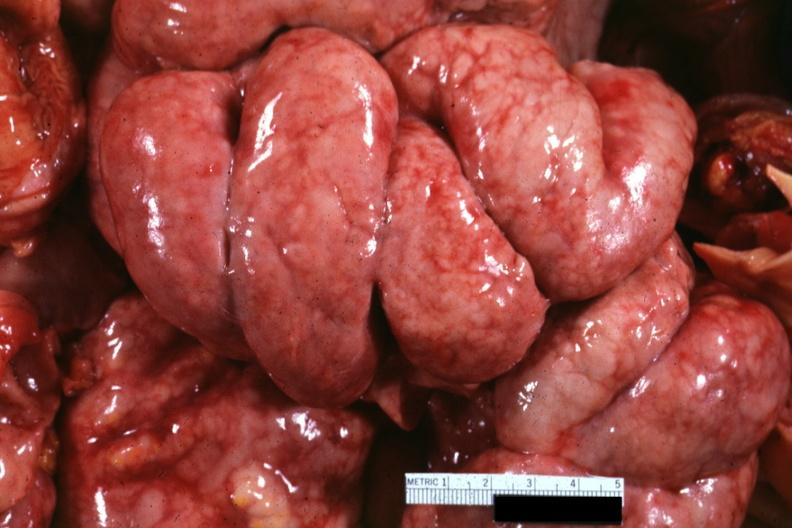what is present?
Answer the question using a single word or phrase. Abdomen 